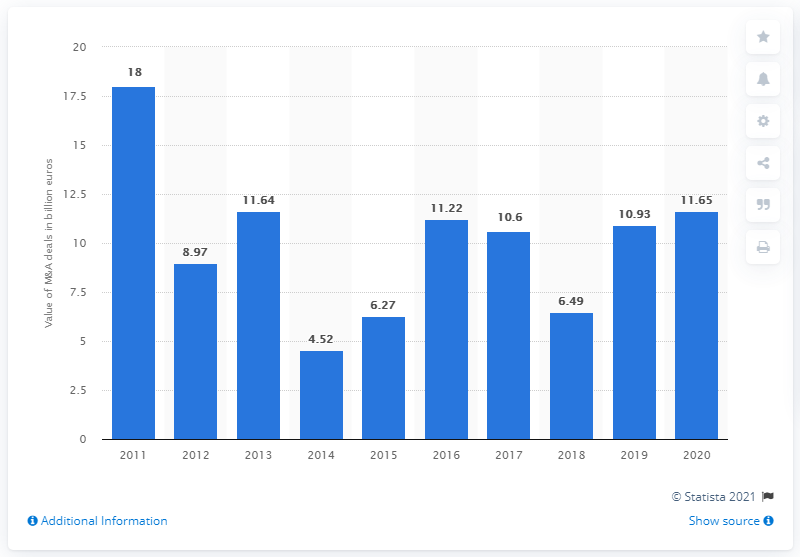Specify some key components in this picture. In 2011, the value of merger deals was 18... In 2020, the value of merger deals in Poland was 11.65. 